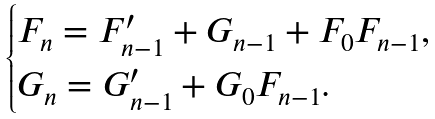<formula> <loc_0><loc_0><loc_500><loc_500>\begin{cases} { F _ { n } = F _ { n - 1 } ^ { \prime } + G _ { n - 1 } + F _ { 0 } F _ { n - 1 } } , \\ G _ { n } = G _ { n - 1 } ^ { \prime } + G _ { 0 } F _ { n - 1 } . \end{cases}</formula> 